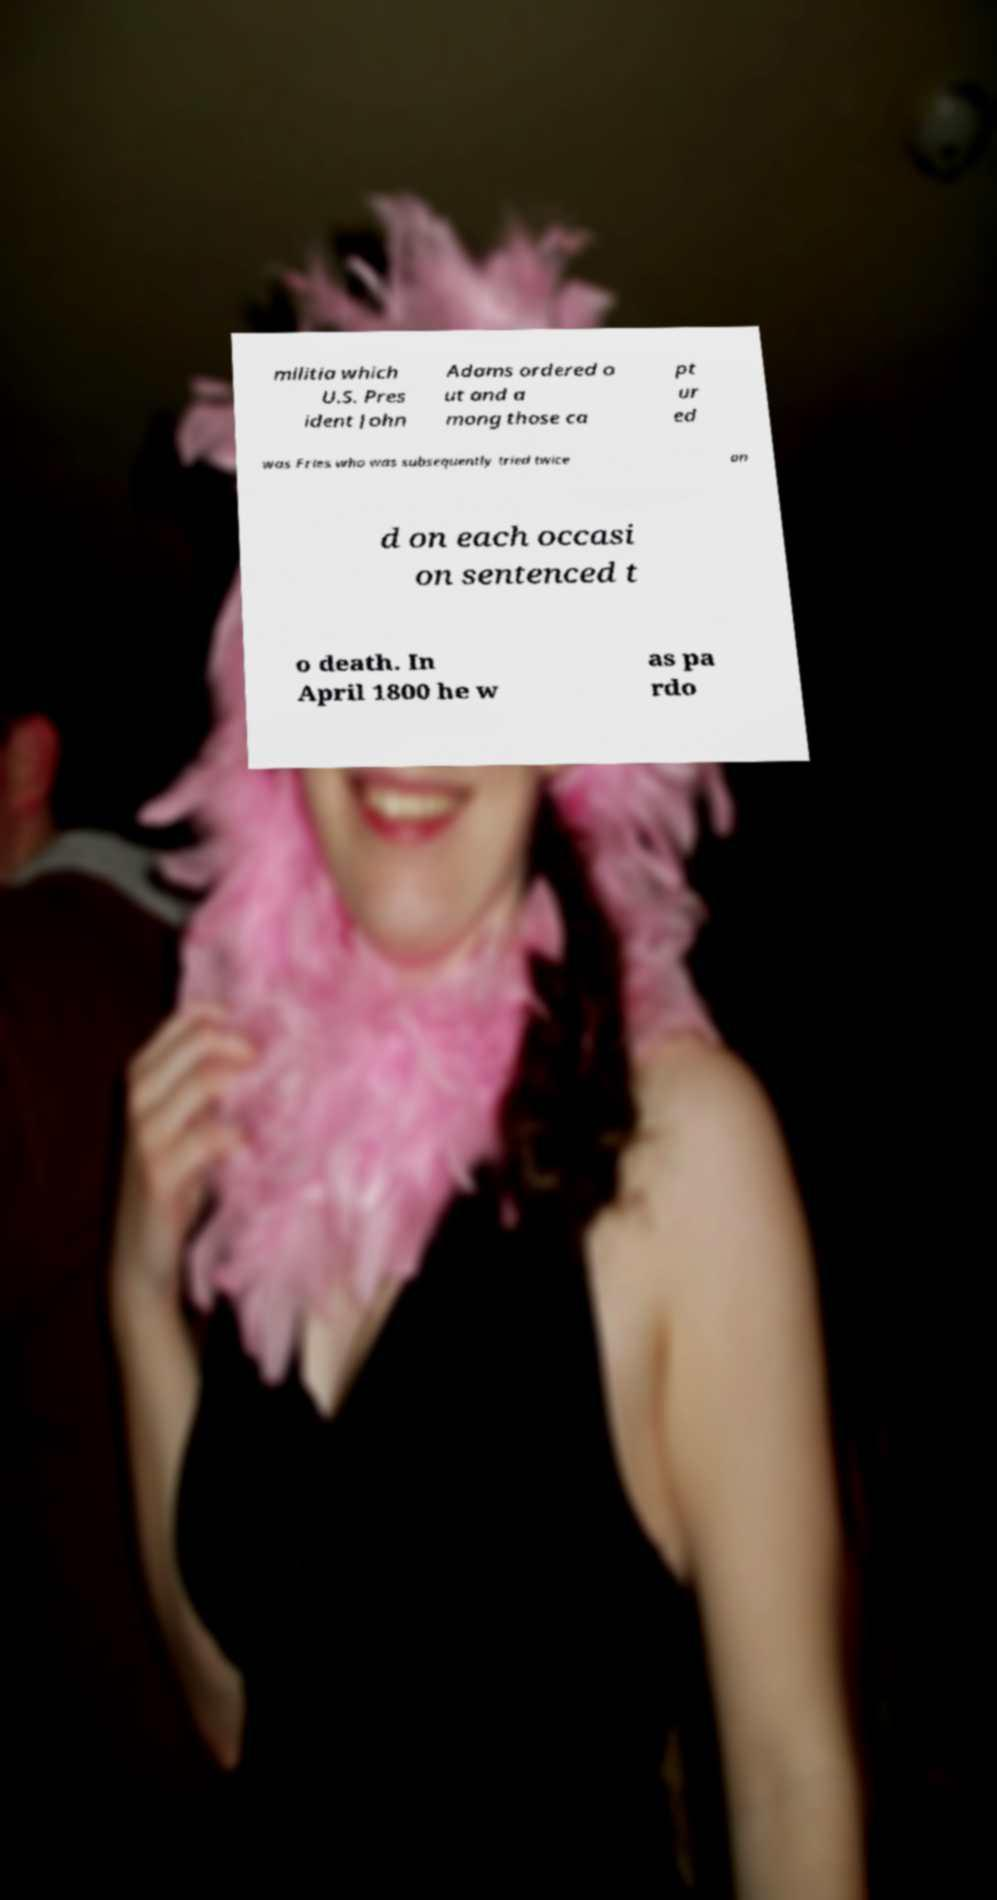Please read and relay the text visible in this image. What does it say? militia which U.S. Pres ident John Adams ordered o ut and a mong those ca pt ur ed was Fries who was subsequently tried twice an d on each occasi on sentenced t o death. In April 1800 he w as pa rdo 